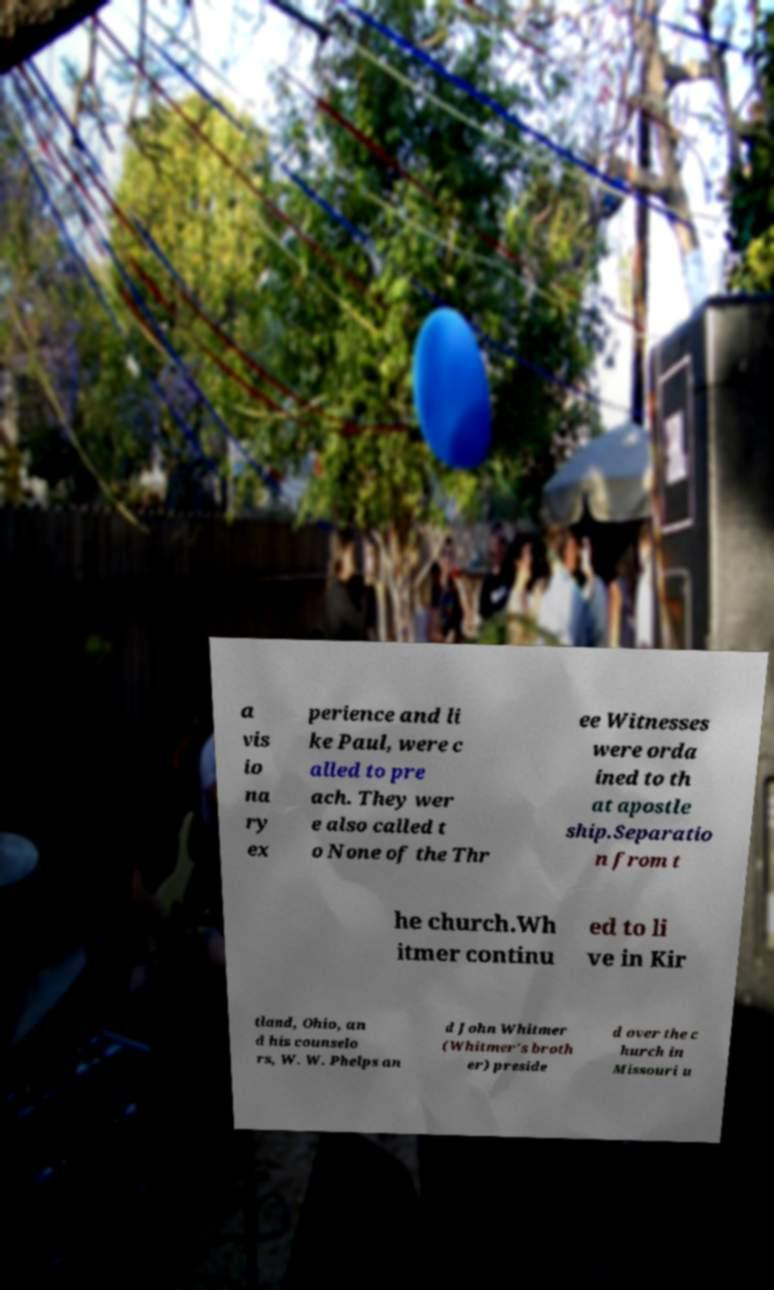Please identify and transcribe the text found in this image. a vis io na ry ex perience and li ke Paul, were c alled to pre ach. They wer e also called t o None of the Thr ee Witnesses were orda ined to th at apostle ship.Separatio n from t he church.Wh itmer continu ed to li ve in Kir tland, Ohio, an d his counselo rs, W. W. Phelps an d John Whitmer (Whitmer's broth er) preside d over the c hurch in Missouri u 